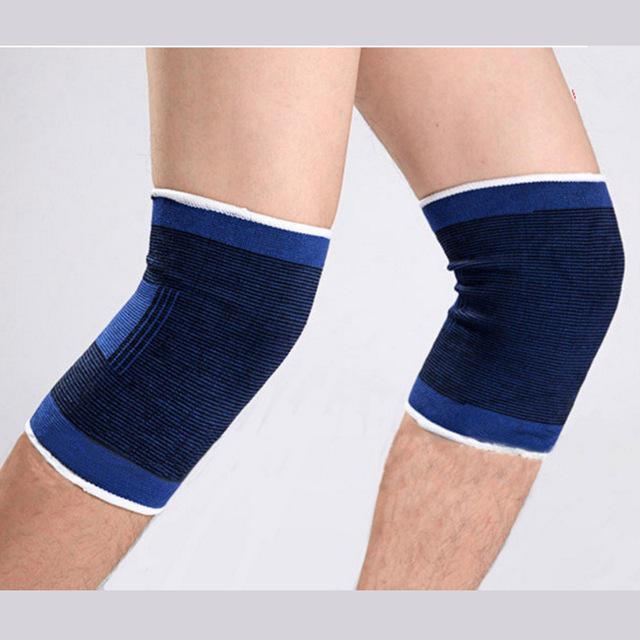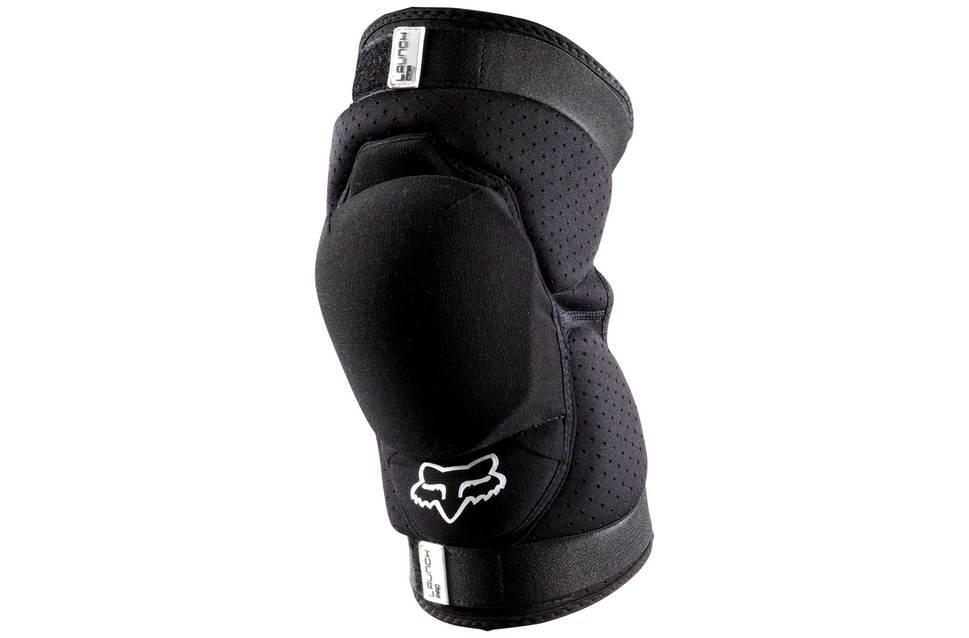The first image is the image on the left, the second image is the image on the right. For the images shown, is this caption "There are exactly two knee braces." true? Answer yes or no. No. The first image is the image on the left, the second image is the image on the right. For the images shown, is this caption "Exactly two kneepads are modeled on human legs, both of the pads black with a logo, but different designs." true? Answer yes or no. No. 